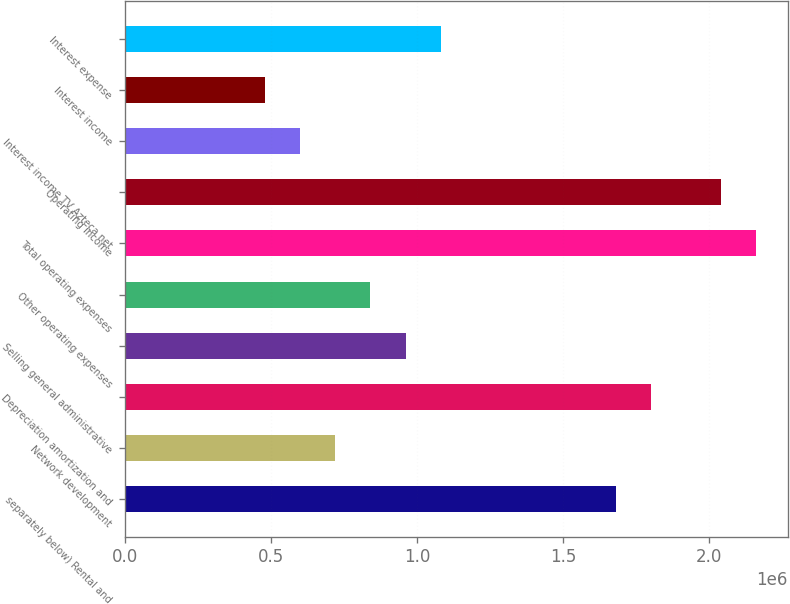Convert chart. <chart><loc_0><loc_0><loc_500><loc_500><bar_chart><fcel>separately below) Rental and<fcel>Network development<fcel>Depreciation amortization and<fcel>Selling general administrative<fcel>Other operating expenses<fcel>Total operating expenses<fcel>Operating income<fcel>Interest income TV Azteca net<fcel>Interest income<fcel>Interest expense<nl><fcel>1.68134e+06<fcel>720575<fcel>1.80144e+06<fcel>960766<fcel>840670<fcel>2.16172e+06<fcel>2.04163e+06<fcel>600479<fcel>480383<fcel>1.08086e+06<nl></chart> 